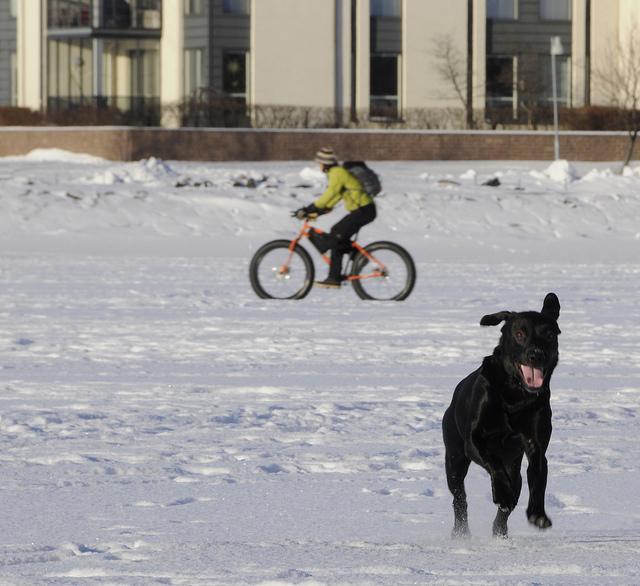How many people are riding bikes here?
Keep it brief. 1. Is the dog's mouth opened or closed?
Keep it brief. Open. Is the dog wearing paw boots?
Keep it brief. No. What is in this dogs mouth?
Write a very short answer. Tongue. Is the dog looking at the camera?
Be succinct. Yes. 